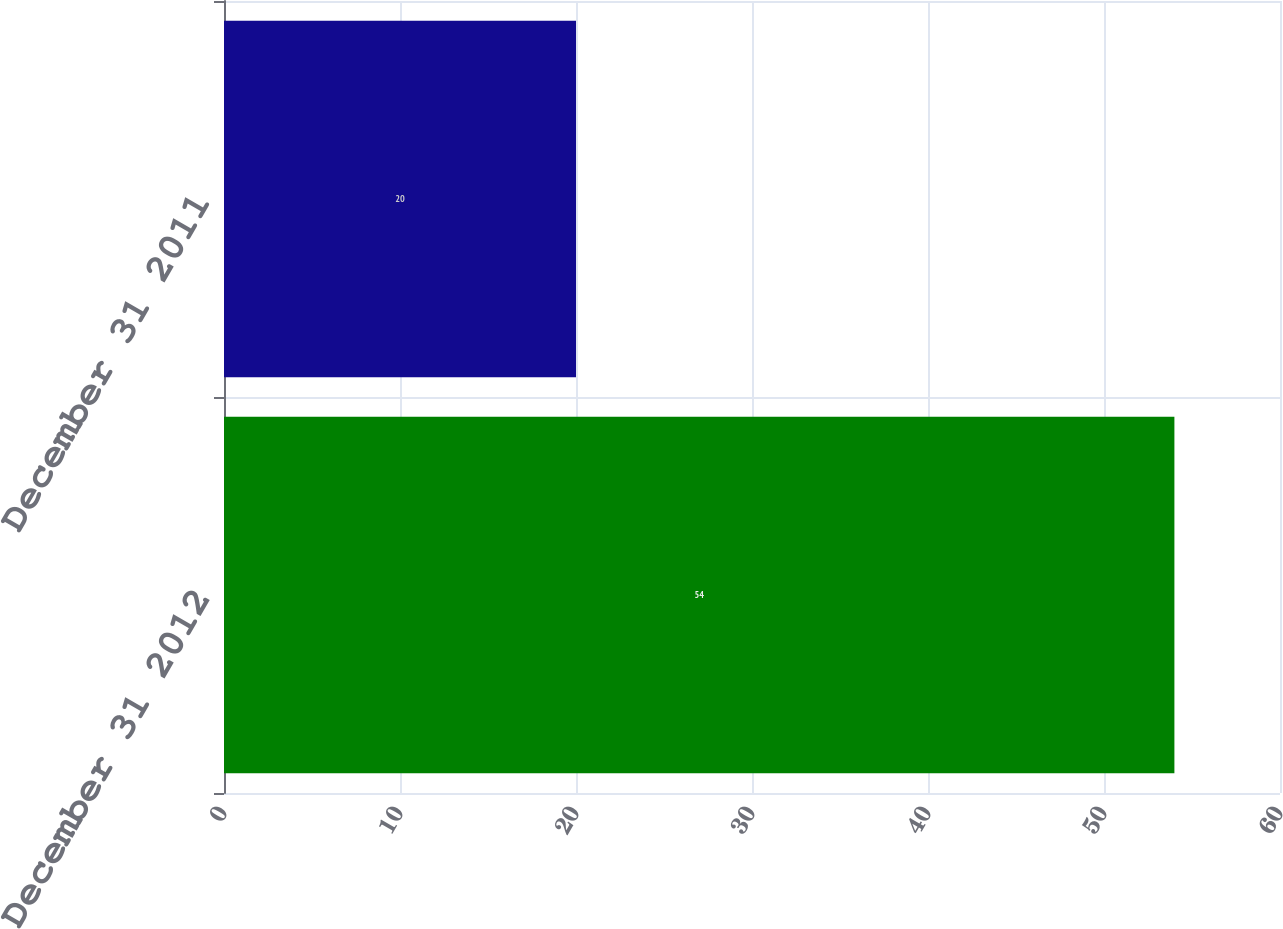Convert chart to OTSL. <chart><loc_0><loc_0><loc_500><loc_500><bar_chart><fcel>December 31 2012<fcel>December 31 2011<nl><fcel>54<fcel>20<nl></chart> 